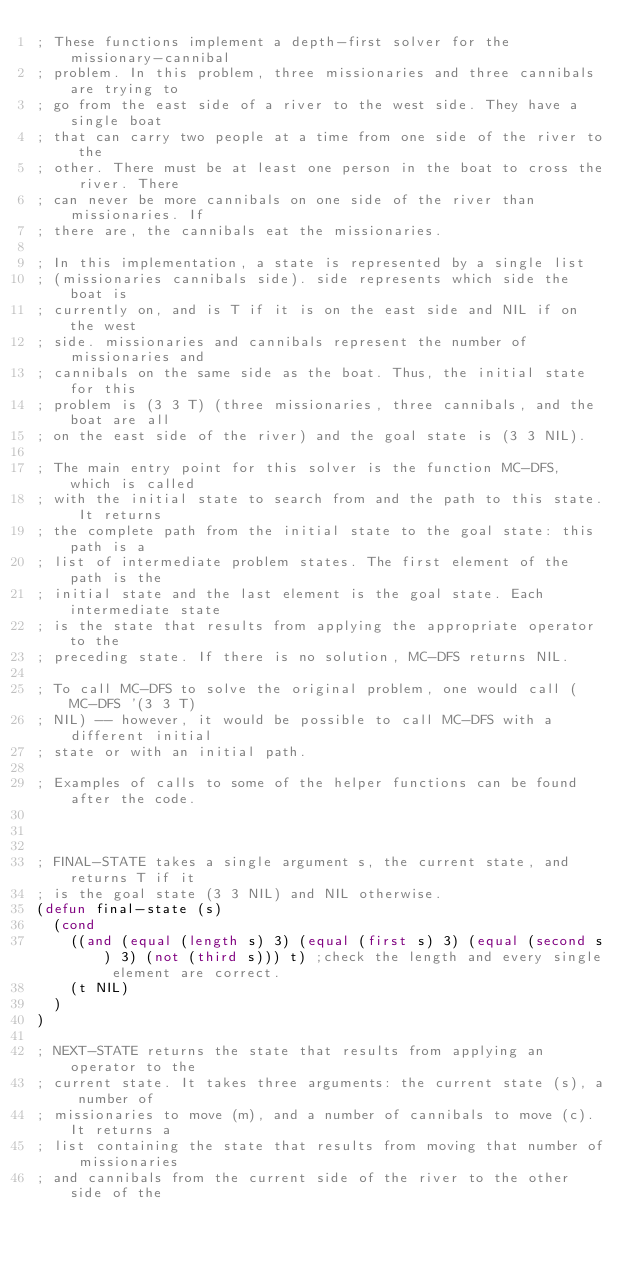<code> <loc_0><loc_0><loc_500><loc_500><_Lisp_>; These functions implement a depth-first solver for the missionary-cannibal
; problem. In this problem, three missionaries and three cannibals are trying to
; go from the east side of a river to the west side. They have a single boat
; that can carry two people at a time from one side of the river to the
; other. There must be at least one person in the boat to cross the river. There
; can never be more cannibals on one side of the river than missionaries. If
; there are, the cannibals eat the missionaries.

; In this implementation, a state is represented by a single list
; (missionaries cannibals side). side represents which side the boat is
; currently on, and is T if it is on the east side and NIL if on the west
; side. missionaries and cannibals represent the number of missionaries and
; cannibals on the same side as the boat. Thus, the initial state for this
; problem is (3 3 T) (three missionaries, three cannibals, and the boat are all
; on the east side of the river) and the goal state is (3 3 NIL).

; The main entry point for this solver is the function MC-DFS, which is called
; with the initial state to search from and the path to this state. It returns
; the complete path from the initial state to the goal state: this path is a
; list of intermediate problem states. The first element of the path is the
; initial state and the last element is the goal state. Each intermediate state
; is the state that results from applying the appropriate operator to the
; preceding state. If there is no solution, MC-DFS returns NIL.

; To call MC-DFS to solve the original problem, one would call (MC-DFS '(3 3 T)
; NIL) -- however, it would be possible to call MC-DFS with a different initial
; state or with an initial path.

; Examples of calls to some of the helper functions can be found after the code.



; FINAL-STATE takes a single argument s, the current state, and returns T if it
; is the goal state (3 3 NIL) and NIL otherwise.
(defun final-state (s)
  (cond
    ((and (equal (length s) 3) (equal (first s) 3) (equal (second s) 3) (not (third s))) t) ;check the length and every single element are correct. 
    (t NIL)
  )
)

; NEXT-STATE returns the state that results from applying an operator to the
; current state. It takes three arguments: the current state (s), a number of
; missionaries to move (m), and a number of cannibals to move (c). It returns a
; list containing the state that results from moving that number of missionaries
; and cannibals from the current side of the river to the other side of the</code> 